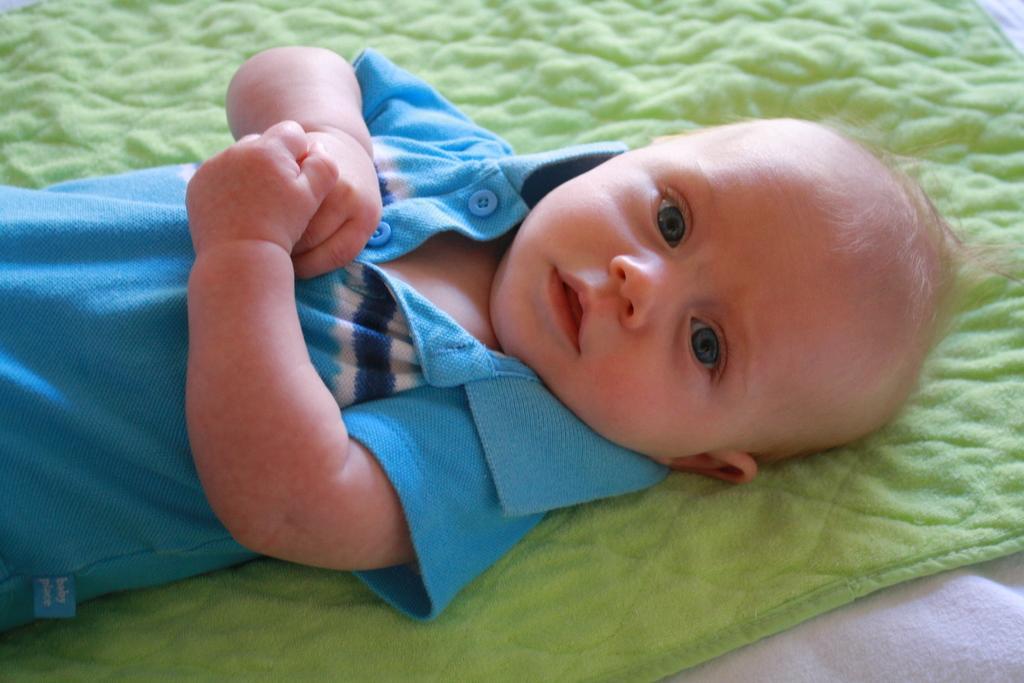Could you give a brief overview of what you see in this image? In this image I can see a baby is sleeping on the green color cloth. This baby wore blue color t-shirt, at the bottom there is white color cloth 